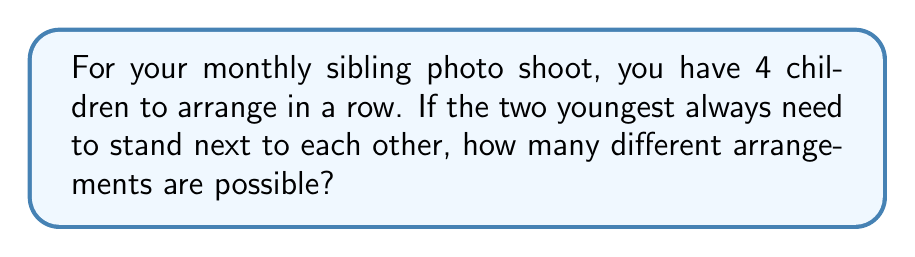Teach me how to tackle this problem. Let's approach this step-by-step:

1) First, consider the two youngest children as a single unit. This means we now have 3 units to arrange: the two oldest children and the unit of the two youngest.

2) The number of ways to arrange 3 distinct units is given by the factorial of 3:

   $$3! = 3 \times 2 \times 1 = 6$$

3) However, for each of these 6 arrangements, the two youngest children can swap positions with each other. This doubles our possibilities:

   $$6 \times 2 = 12$$

4) Therefore, the total number of possible arrangements is 12.

This can also be derived using the multiplication principle:
- We have 4 positions to fill.
- The unit of two youngest children can be placed in 3 ways (left, middle, right).
- The remaining 2 children can be arranged in 2! = 2 ways.
- The 2 youngest can be arranged among themselves in 2! = 2 ways.

So, $$3 \times 2! \times 2! = 3 \times 2 \times 2 = 12$$
Answer: 12 arrangements 